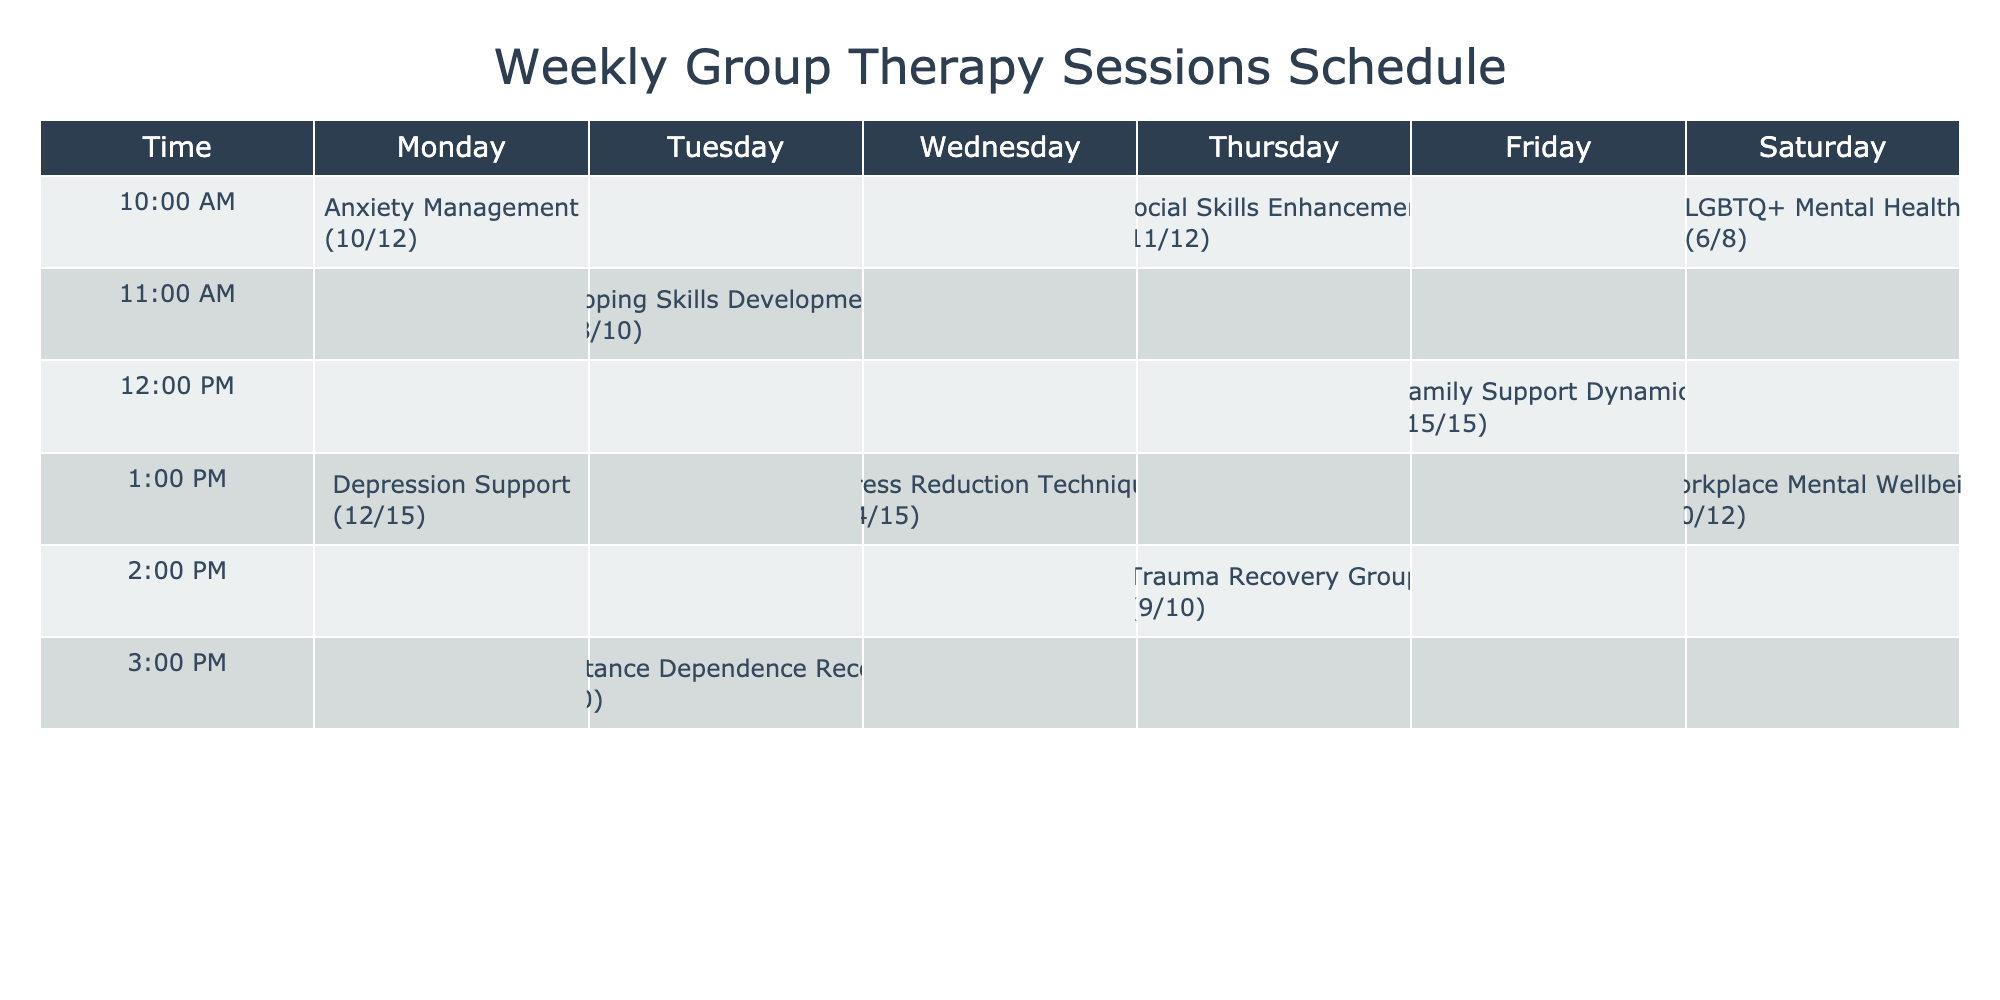What group has the highest attendance rate? The attendance rates are as follows: Anxiety Management (10), Depression Support (12), Coping Skills Development (8), Substance Dependence Recovery (7), Stress Reduction Techniques (14), Social Skills Enhancement (11), Trauma Recovery Group (9), Family Support Dynamics (15), LGBTQ+ Mental Health (6), and Workplace Mental Wellbeing (10). The highest attendance rate is 15 for Family Support Dynamics.
Answer: Family Support Dynamics How many sessions are held on Wednesdays? From the table, only one group, Stress Reduction Techniques, is scheduled on Wednesday at 1:00 PM. Therefore, there is only one session on that day.
Answer: 1 What is the average attendance rate across all sessions? To calculate the average attendance rate, we sum the rates: 10 + 12 + 8 + 7 + 14 + 11 + 9 + 15 + 6 + 10 = 92. There are 10 sessions, so we divide the total (92) by the number of sessions (10), giving us an average of 9.2.
Answer: 9.2 Is there a support group for anxiety on Tuesday? Review the table to find the groups scheduled that day: Coping Skills Development (8) and Substance Dependence Recovery (7). Neither of these groups is specifically for anxiety; thus, the answer is no.
Answer: No What is the difference in attendance rates between the highest and lowest groups? The highest attendance rate is 15 (Family Support Dynamics) and the lowest is 6 (LGBTQ+ Mental Health). The difference is calculated as 15 - 6 = 9.
Answer: 9 Which day has the maximum number of participants for group therapy? The attendance rates for each day are: Monday (22), Tuesday (15), Wednesday (14), Thursday (20), Friday (15), and Saturday (16). The maximum count occurs on Monday, where a total of 22 participants attended (10 + 12).
Answer: Monday 